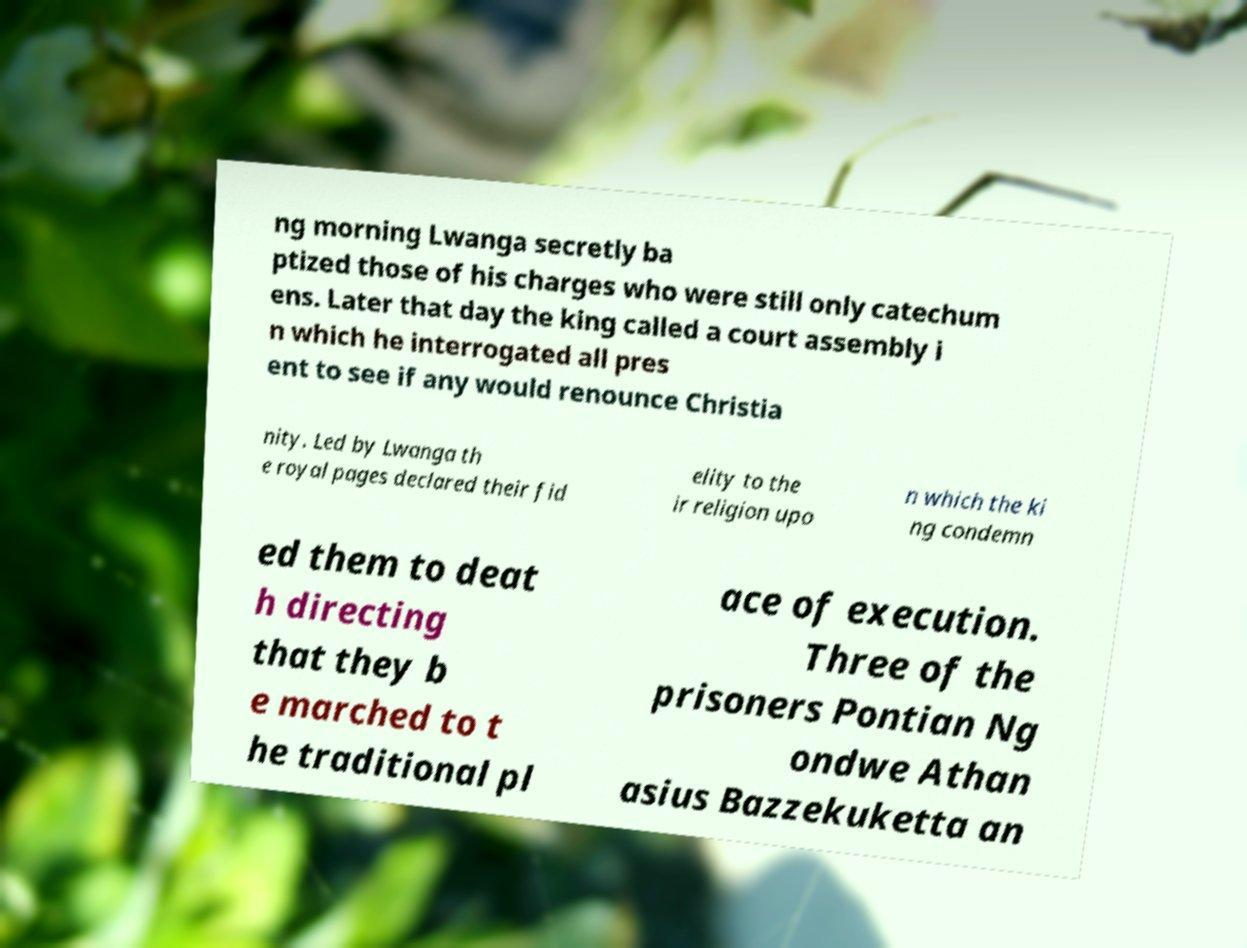What messages or text are displayed in this image? I need them in a readable, typed format. ng morning Lwanga secretly ba ptized those of his charges who were still only catechum ens. Later that day the king called a court assembly i n which he interrogated all pres ent to see if any would renounce Christia nity. Led by Lwanga th e royal pages declared their fid elity to the ir religion upo n which the ki ng condemn ed them to deat h directing that they b e marched to t he traditional pl ace of execution. Three of the prisoners Pontian Ng ondwe Athan asius Bazzekuketta an 